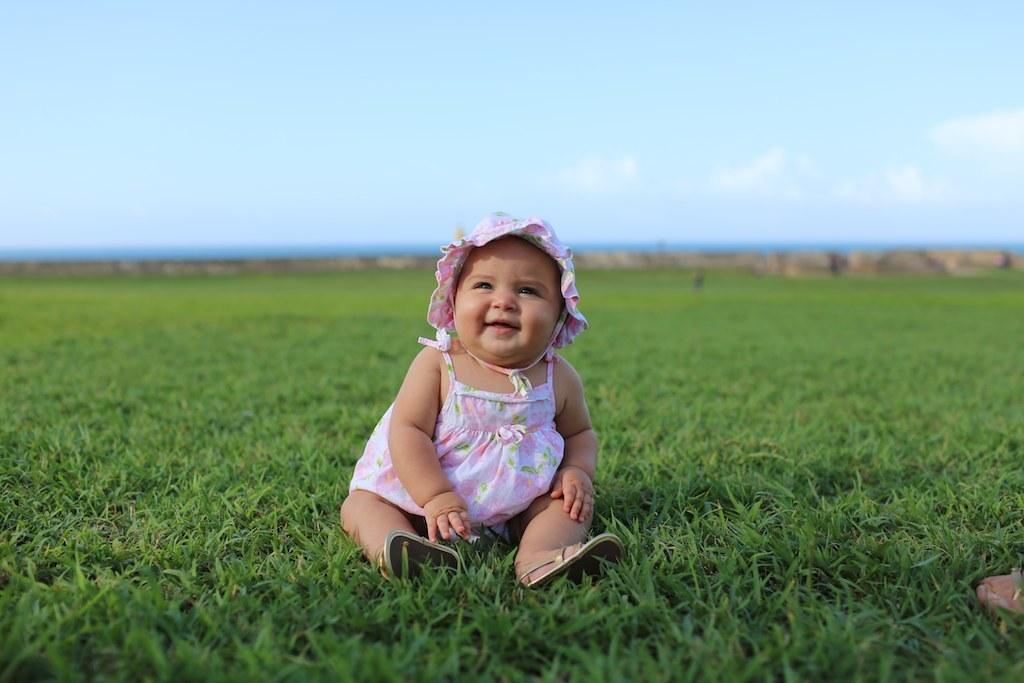What is the main subject of the image? There is a baby sitting in the image. What is the baby wearing? The baby is wearing a white and pink color frock. What can be seen in the background of the image? The background of the image includes green grass and a blue sky. What type of peace agreement is being discussed in the image? There is no indication of a peace agreement or any discussion in the image; it features a baby sitting in a white and pink frock with a green grass and blue sky background. 